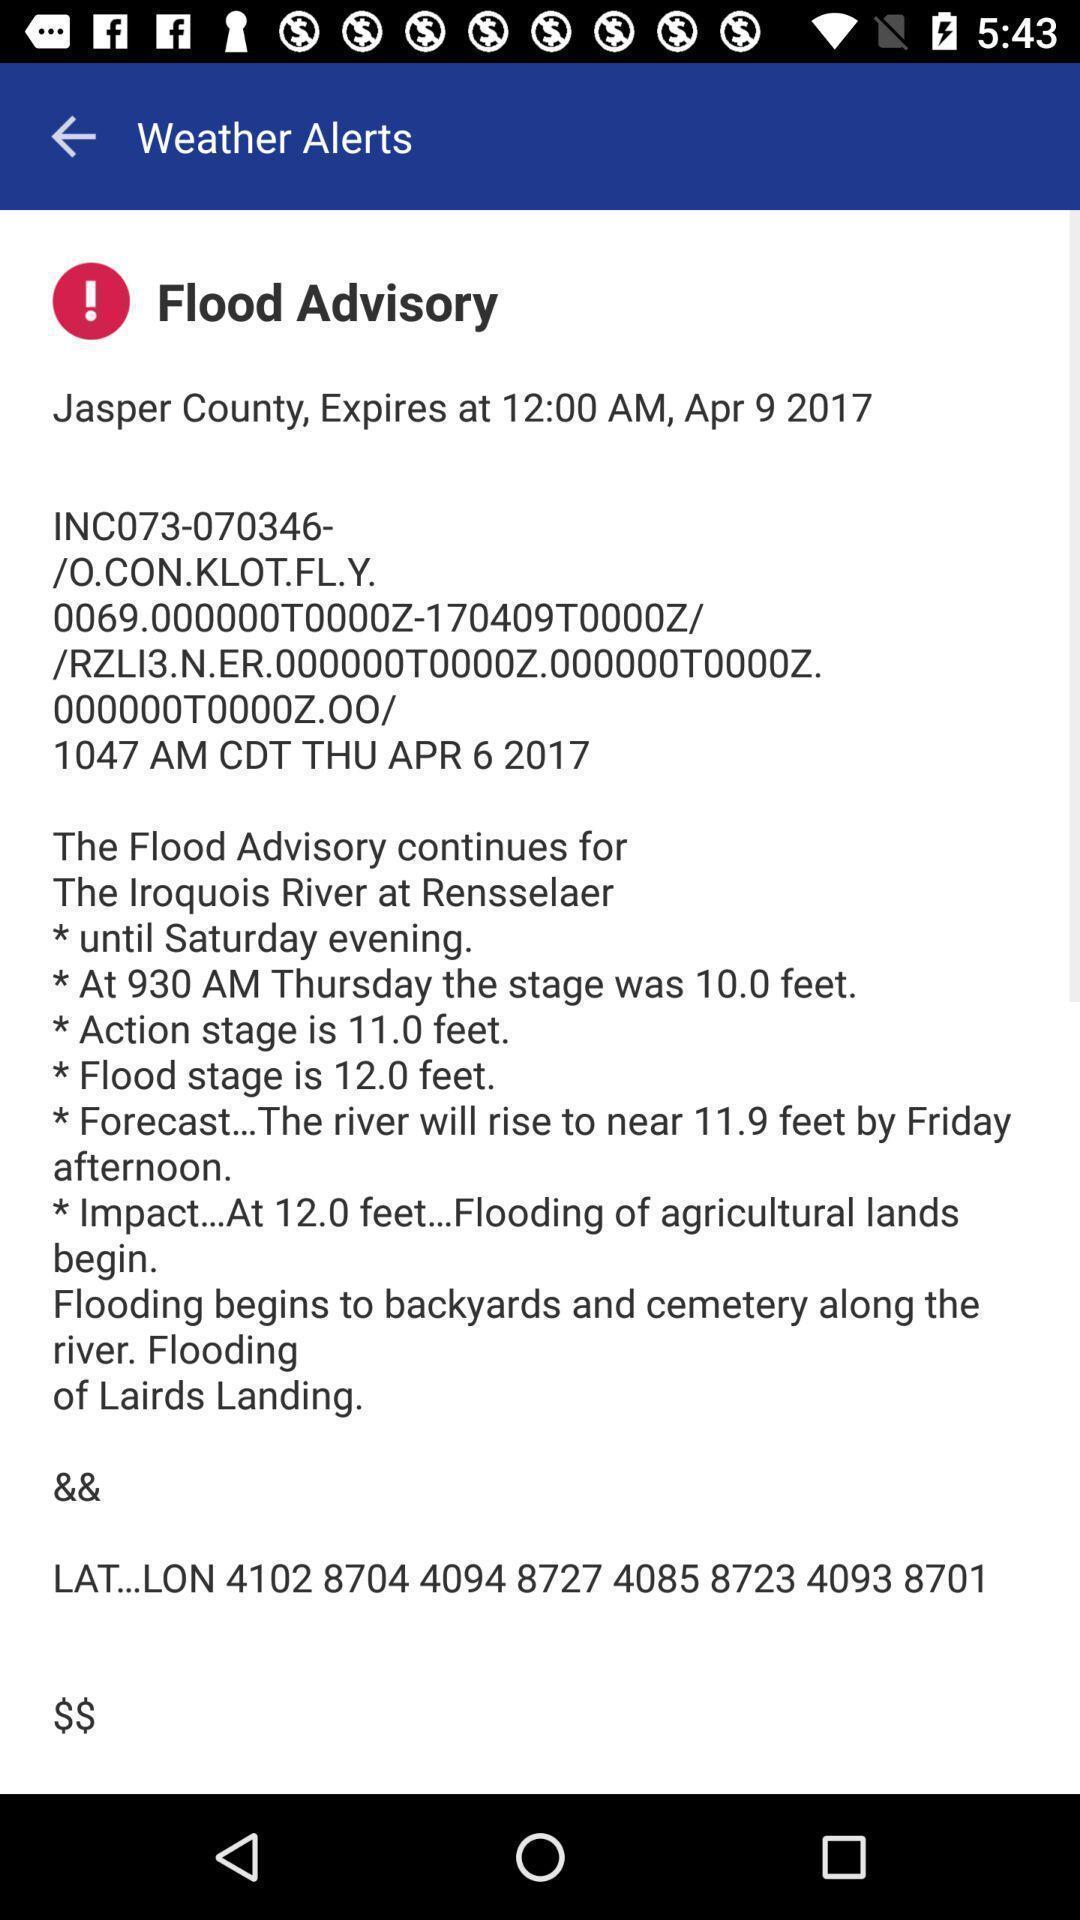Tell me what you see in this picture. Window displaying all news alerts. 